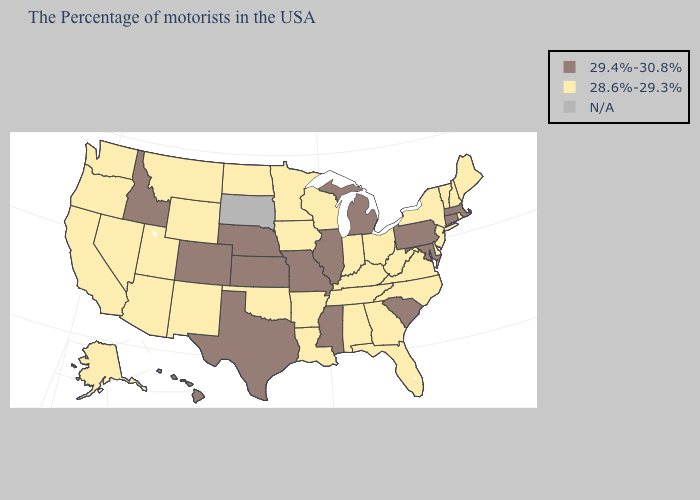What is the highest value in states that border West Virginia?
Short answer required. 29.4%-30.8%. Name the states that have a value in the range 29.4%-30.8%?
Quick response, please. Massachusetts, Connecticut, Maryland, Pennsylvania, South Carolina, Michigan, Illinois, Mississippi, Missouri, Kansas, Nebraska, Texas, Colorado, Idaho, Hawaii. How many symbols are there in the legend?
Keep it brief. 3. Does the first symbol in the legend represent the smallest category?
Give a very brief answer. No. Name the states that have a value in the range N/A?
Concise answer only. South Dakota. Which states have the lowest value in the USA?
Answer briefly. Maine, Rhode Island, New Hampshire, Vermont, New York, New Jersey, Delaware, Virginia, North Carolina, West Virginia, Ohio, Florida, Georgia, Kentucky, Indiana, Alabama, Tennessee, Wisconsin, Louisiana, Arkansas, Minnesota, Iowa, Oklahoma, North Dakota, Wyoming, New Mexico, Utah, Montana, Arizona, Nevada, California, Washington, Oregon, Alaska. Does the first symbol in the legend represent the smallest category?
Quick response, please. No. Name the states that have a value in the range 28.6%-29.3%?
Be succinct. Maine, Rhode Island, New Hampshire, Vermont, New York, New Jersey, Delaware, Virginia, North Carolina, West Virginia, Ohio, Florida, Georgia, Kentucky, Indiana, Alabama, Tennessee, Wisconsin, Louisiana, Arkansas, Minnesota, Iowa, Oklahoma, North Dakota, Wyoming, New Mexico, Utah, Montana, Arizona, Nevada, California, Washington, Oregon, Alaska. Is the legend a continuous bar?
Answer briefly. No. What is the highest value in states that border California?
Concise answer only. 28.6%-29.3%. What is the value of Arizona?
Give a very brief answer. 28.6%-29.3%. Among the states that border Utah , which have the highest value?
Short answer required. Colorado, Idaho. Among the states that border Florida , which have the highest value?
Concise answer only. Georgia, Alabama. Does Iowa have the highest value in the MidWest?
Quick response, please. No. Among the states that border Alabama , which have the highest value?
Give a very brief answer. Mississippi. 